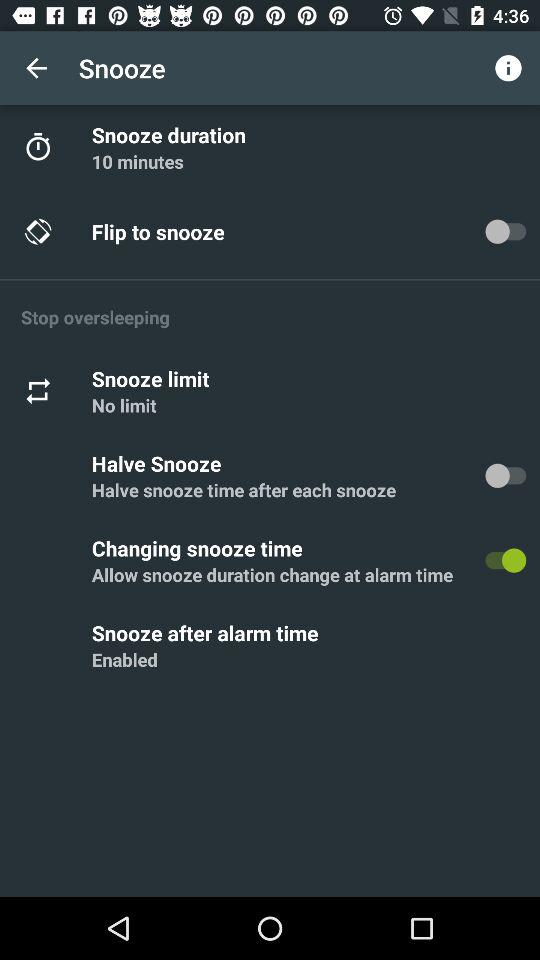Which days are chosen for the alarm?
When the provided information is insufficient, respond with <no answer>. <no answer> 